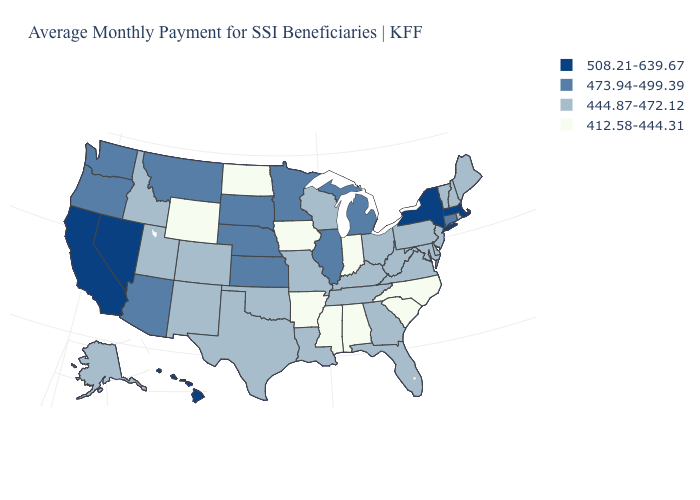Does Indiana have the lowest value in the MidWest?
Be succinct. Yes. What is the value of Utah?
Concise answer only. 444.87-472.12. Does Missouri have a higher value than Idaho?
Answer briefly. No. How many symbols are there in the legend?
Answer briefly. 4. Name the states that have a value in the range 473.94-499.39?
Give a very brief answer. Arizona, Connecticut, Illinois, Kansas, Michigan, Minnesota, Montana, Nebraska, Oregon, South Dakota, Washington. What is the highest value in the West ?
Be succinct. 508.21-639.67. What is the value of Kansas?
Be succinct. 473.94-499.39. Name the states that have a value in the range 508.21-639.67?
Write a very short answer. California, Hawaii, Massachusetts, Nevada, New York. What is the value of North Carolina?
Short answer required. 412.58-444.31. What is the value of Maryland?
Give a very brief answer. 444.87-472.12. What is the value of Wyoming?
Answer briefly. 412.58-444.31. What is the lowest value in states that border New York?
Keep it brief. 444.87-472.12. Name the states that have a value in the range 508.21-639.67?
Keep it brief. California, Hawaii, Massachusetts, Nevada, New York. Does Rhode Island have a lower value than North Carolina?
Keep it brief. No. Name the states that have a value in the range 444.87-472.12?
Give a very brief answer. Alaska, Colorado, Delaware, Florida, Georgia, Idaho, Kentucky, Louisiana, Maine, Maryland, Missouri, New Hampshire, New Jersey, New Mexico, Ohio, Oklahoma, Pennsylvania, Rhode Island, Tennessee, Texas, Utah, Vermont, Virginia, West Virginia, Wisconsin. 